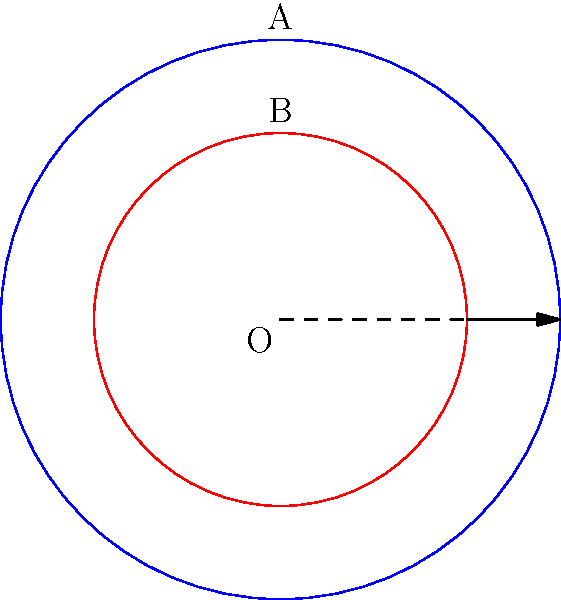In a Southern city during the early stages of desegregation, a journalist created a diagram to represent the demographics of the city. The outer circle A represents the total population, while the inner circle B represents the African American population. If the radius of circle A is 3 units and the radius of circle B is 2 units, what percentage of the total area does the region between circles A and B represent? This percentage symbolizes the proportion of the non-African American population in the city. To solve this problem, we'll follow these steps:

1) First, calculate the areas of both circles:
   Area of circle A: $A_A = \pi r_A^2 = \pi (3)^2 = 9\pi$ square units
   Area of circle B: $A_B = \pi r_B^2 = \pi (2)^2 = 4\pi$ square units

2) The area between circles A and B is the difference between these areas:
   $A_{difference} = A_A - A_B = 9\pi - 4\pi = 5\pi$ square units

3) To find the percentage this represents of the total area, divide by the total area and multiply by 100:

   Percentage = $\frac{A_{difference}}{A_A} \times 100\%$
               = $\frac{5\pi}{9\pi} \times 100\%$
               = $\frac{5}{9} \times 100\%$
               ≈ 55.56\%$

Therefore, the region between circles A and B represents approximately 55.56% of the total area, symbolizing the proportion of the non-African American population in the city during this period of desegregation.
Answer: 55.56% 